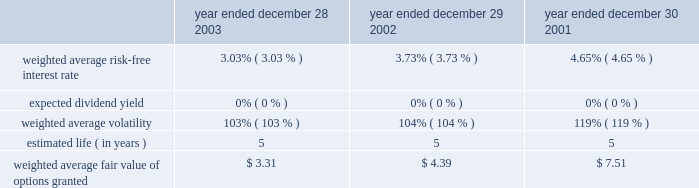Illumina , inc .
Notes to consolidated financial statements 2014 ( continued ) advertising costs the company expenses advertising costs as incurred .
Advertising costs were approximately $ 440000 for 2003 , $ 267000 for 2002 and $ 57000 for 2001 .
Income taxes a deferred income tax asset or liability is computed for the expected future impact of differences between the financial reporting and tax bases of assets and liabilities , as well as the expected future tax benefit to be derived from tax loss and credit carryforwards .
Deferred income tax expense is generally the net change during the year in the deferred income tax asset or liability .
Valuation allowances are established when realizability of deferred tax assets is uncertain .
The effect of tax rate changes is reflected in tax expense during the period in which such changes are enacted .
Foreign currency translation the functional currencies of the company 2019s wholly owned subsidiaries are their respective local currencies .
Accordingly , all balance sheet accounts of these operations are translated to u.s .
Dollars using the exchange rates in effect at the balance sheet date , and revenues and expenses are translated using the average exchange rates in effect during the period .
The gains and losses from foreign currency translation of these subsidiaries 2019 financial statements are recorded directly as a separate component of stockholders 2019 equity under the caption 2018 2018accumulated other comprehensive income . 2019 2019 stock-based compensation at december 28 , 2003 , the company has three stock-based employee and non-employee director compensation plans , which are described more fully in note 5 .
As permitted by sfas no .
123 , accounting for stock-based compensation , the company accounts for common stock options granted , and restricted stock sold , to employees , founders and directors using the intrinsic value method and , thus , recognizes no compensation expense for options granted , or restricted stock sold , with exercise prices equal to or greater than the fair value of the company 2019s common stock on the date of the grant .
The company has recorded deferred stock compensation related to certain stock options , and restricted stock , which were granted prior to the company 2019s initial public offering with exercise prices below estimated fair value ( see note 5 ) , which is being amortized on an accelerated amortiza- tion methodology in accordance with financial accounting standards board interpretation number ( 2018 2018fin 2019 2019 ) 28 .
Pro forma information regarding net loss is required by sfas no .
123 and has been determined as if the company had accounted for its employee stock options and employee stock purchases under the fair value method of that statement .
The fair value for these options was estimated at the dates of grant using the fair value option pricing model ( black scholes ) with the following weighted-average assumptions for 2003 , 2002 and 2001 : year ended year ended year ended december 28 , december 29 , december 30 , 2003 2002 2001 weighted average risk-free interest rate******* 3.03% ( 3.03 % ) 3.73% ( 3.73 % ) 4.65% ( 4.65 % ) expected dividend yield********************* 0% ( 0 % ) 0% ( 0 % ) 0% ( 0 % ) weighted average volatility ****************** 103% ( 103 % ) 104% ( 104 % ) 119% ( 119 % ) estimated life ( in years ) ********************** 5 5 5 .

What was the change in advertising costs from 2002 to 2003? 
Computations: (440000 - 267000)
Answer: 173000.0. Illumina , inc .
Notes to consolidated financial statements 2014 ( continued ) advertising costs the company expenses advertising costs as incurred .
Advertising costs were approximately $ 440000 for 2003 , $ 267000 for 2002 and $ 57000 for 2001 .
Income taxes a deferred income tax asset or liability is computed for the expected future impact of differences between the financial reporting and tax bases of assets and liabilities , as well as the expected future tax benefit to be derived from tax loss and credit carryforwards .
Deferred income tax expense is generally the net change during the year in the deferred income tax asset or liability .
Valuation allowances are established when realizability of deferred tax assets is uncertain .
The effect of tax rate changes is reflected in tax expense during the period in which such changes are enacted .
Foreign currency translation the functional currencies of the company 2019s wholly owned subsidiaries are their respective local currencies .
Accordingly , all balance sheet accounts of these operations are translated to u.s .
Dollars using the exchange rates in effect at the balance sheet date , and revenues and expenses are translated using the average exchange rates in effect during the period .
The gains and losses from foreign currency translation of these subsidiaries 2019 financial statements are recorded directly as a separate component of stockholders 2019 equity under the caption 2018 2018accumulated other comprehensive income . 2019 2019 stock-based compensation at december 28 , 2003 , the company has three stock-based employee and non-employee director compensation plans , which are described more fully in note 5 .
As permitted by sfas no .
123 , accounting for stock-based compensation , the company accounts for common stock options granted , and restricted stock sold , to employees , founders and directors using the intrinsic value method and , thus , recognizes no compensation expense for options granted , or restricted stock sold , with exercise prices equal to or greater than the fair value of the company 2019s common stock on the date of the grant .
The company has recorded deferred stock compensation related to certain stock options , and restricted stock , which were granted prior to the company 2019s initial public offering with exercise prices below estimated fair value ( see note 5 ) , which is being amortized on an accelerated amortiza- tion methodology in accordance with financial accounting standards board interpretation number ( 2018 2018fin 2019 2019 ) 28 .
Pro forma information regarding net loss is required by sfas no .
123 and has been determined as if the company had accounted for its employee stock options and employee stock purchases under the fair value method of that statement .
The fair value for these options was estimated at the dates of grant using the fair value option pricing model ( black scholes ) with the following weighted-average assumptions for 2003 , 2002 and 2001 : year ended year ended year ended december 28 , december 29 , december 30 , 2003 2002 2001 weighted average risk-free interest rate******* 3.03% ( 3.03 % ) 3.73% ( 3.73 % ) 4.65% ( 4.65 % ) expected dividend yield********************* 0% ( 0 % ) 0% ( 0 % ) 0% ( 0 % ) weighted average volatility ****************** 103% ( 103 % ) 104% ( 104 % ) 119% ( 119 % ) estimated life ( in years ) ********************** 5 5 5 .

What was the change in advertising costs from 2001 to 2002? 
Computations: (267000 - 57000)
Answer: 210000.0. 